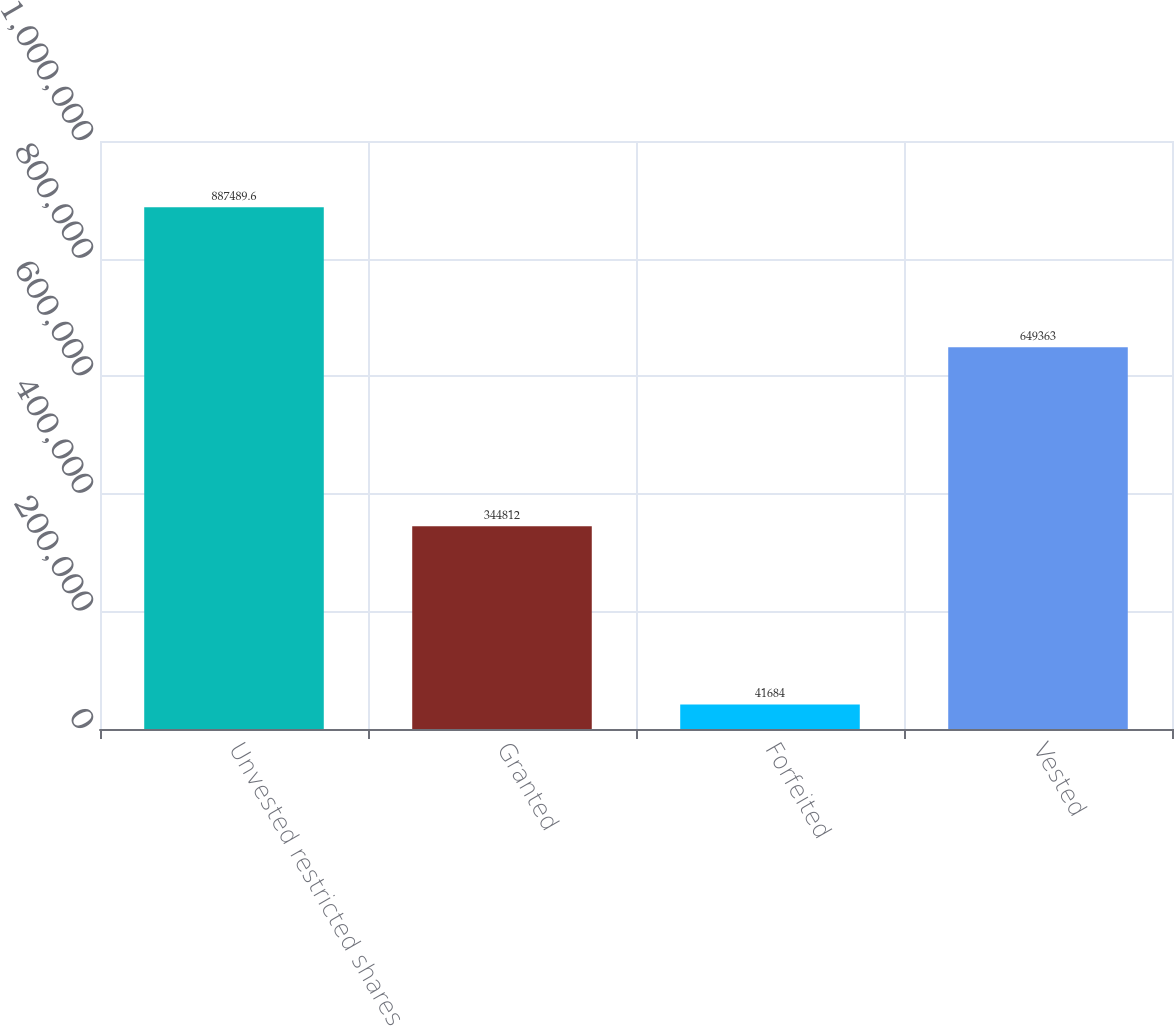Convert chart to OTSL. <chart><loc_0><loc_0><loc_500><loc_500><bar_chart><fcel>Unvested restricted shares<fcel>Granted<fcel>Forfeited<fcel>Vested<nl><fcel>887490<fcel>344812<fcel>41684<fcel>649363<nl></chart> 